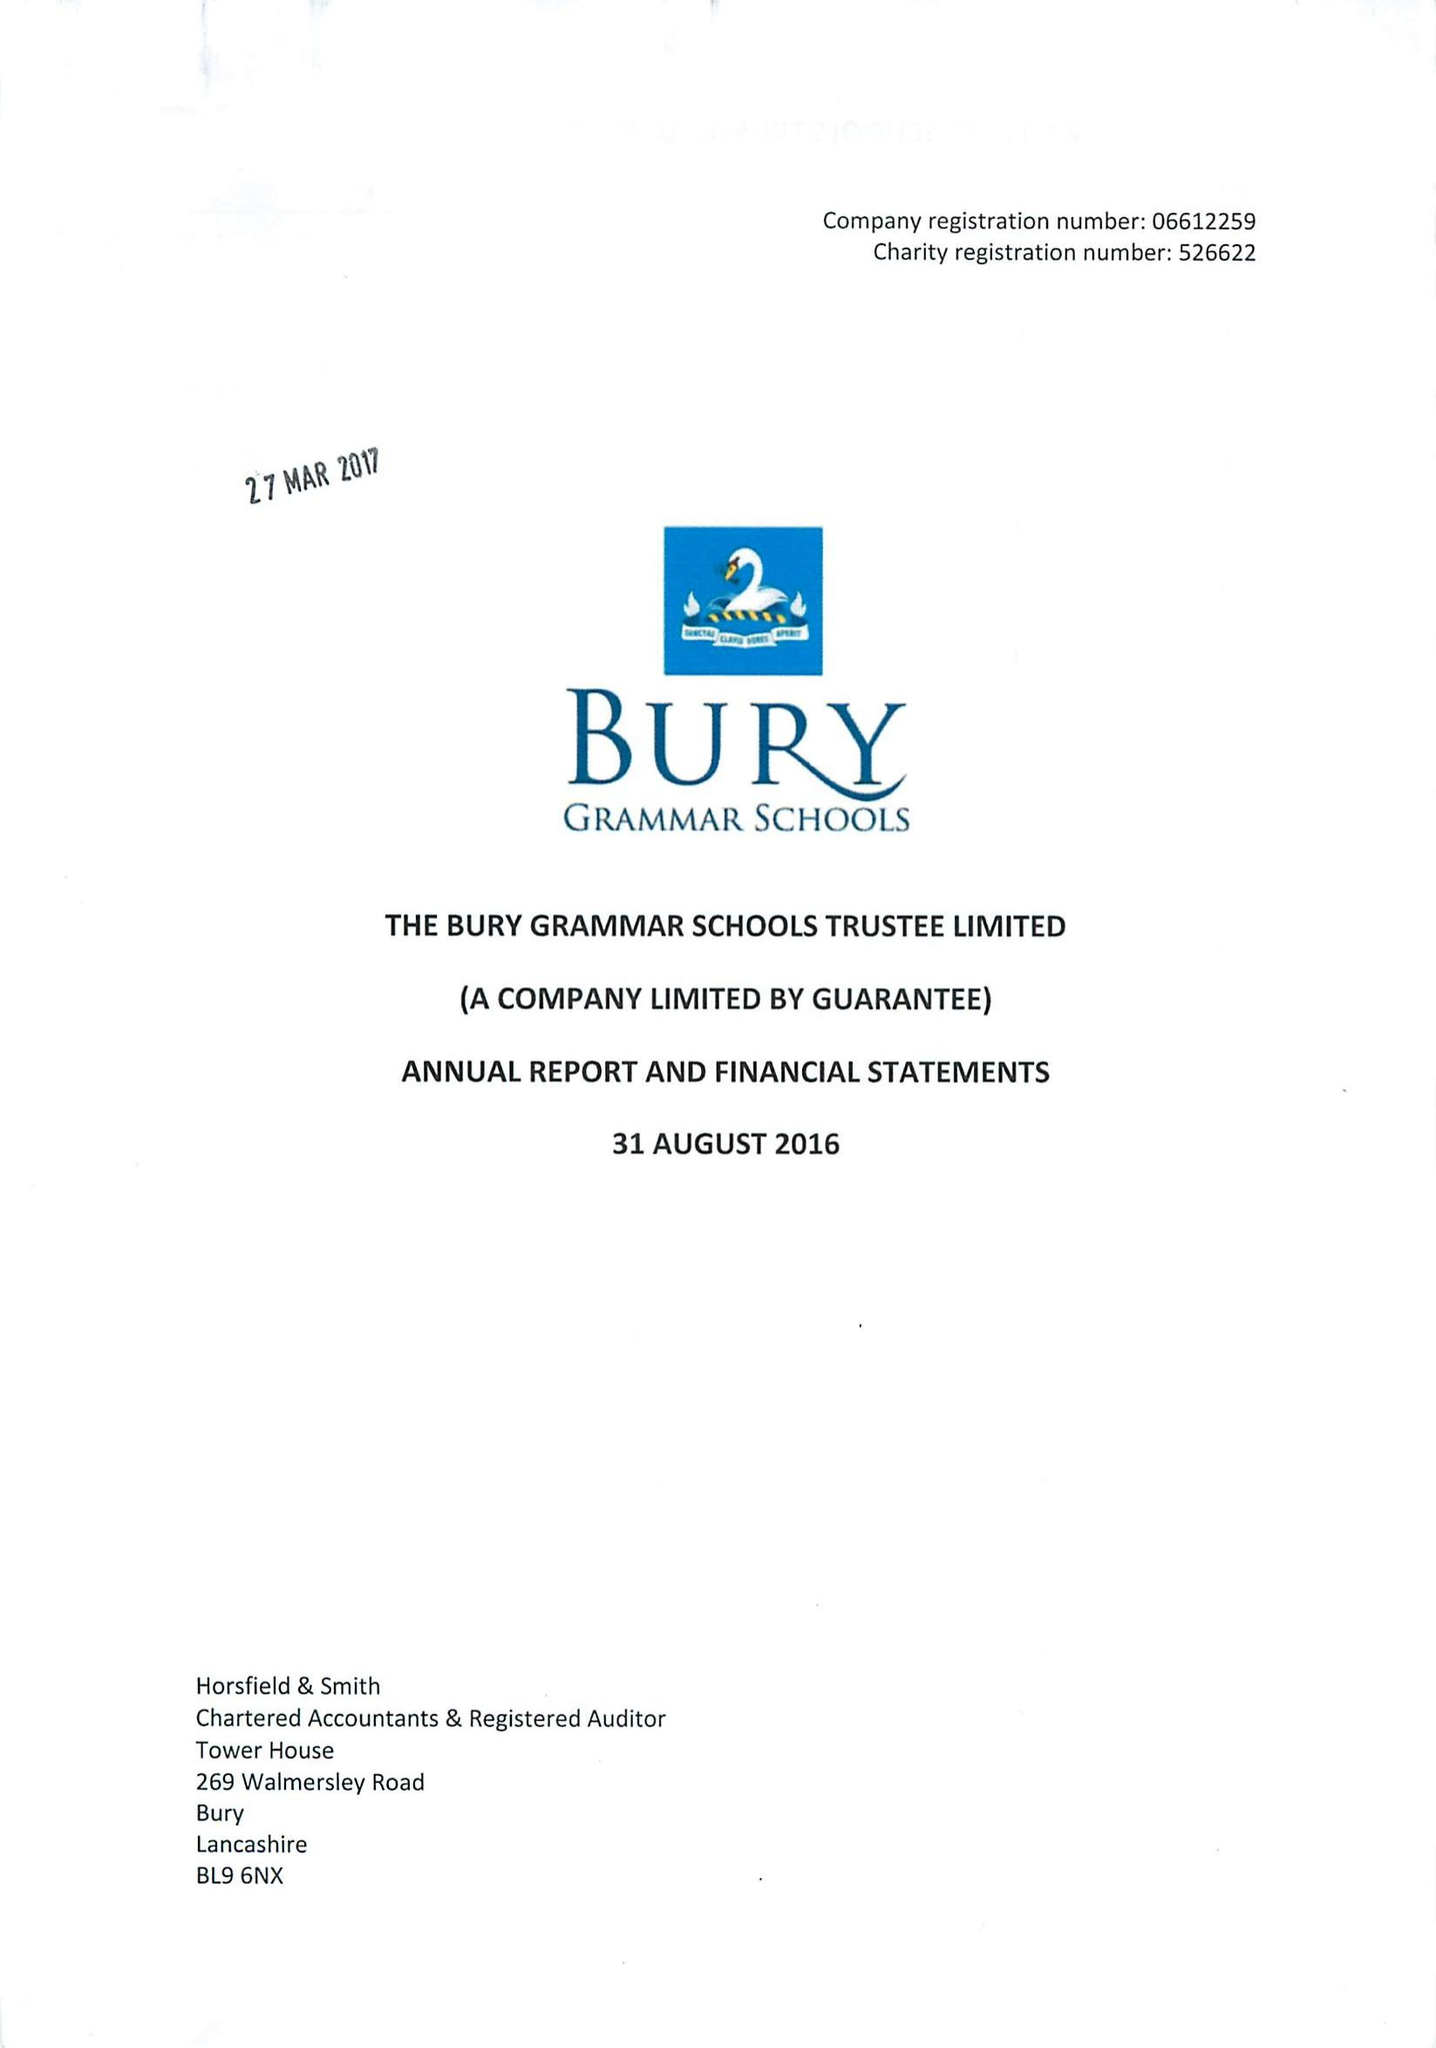What is the value for the spending_annually_in_british_pounds?
Answer the question using a single word or phrase. 12197000.00 